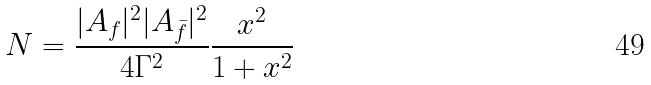Convert formula to latex. <formula><loc_0><loc_0><loc_500><loc_500>N = \frac { | A _ { f } | ^ { 2 } | A _ { \bar { f } } | ^ { 2 } } { 4 \Gamma ^ { 2 } } \frac { x ^ { 2 } } { 1 + x ^ { 2 } }</formula> 